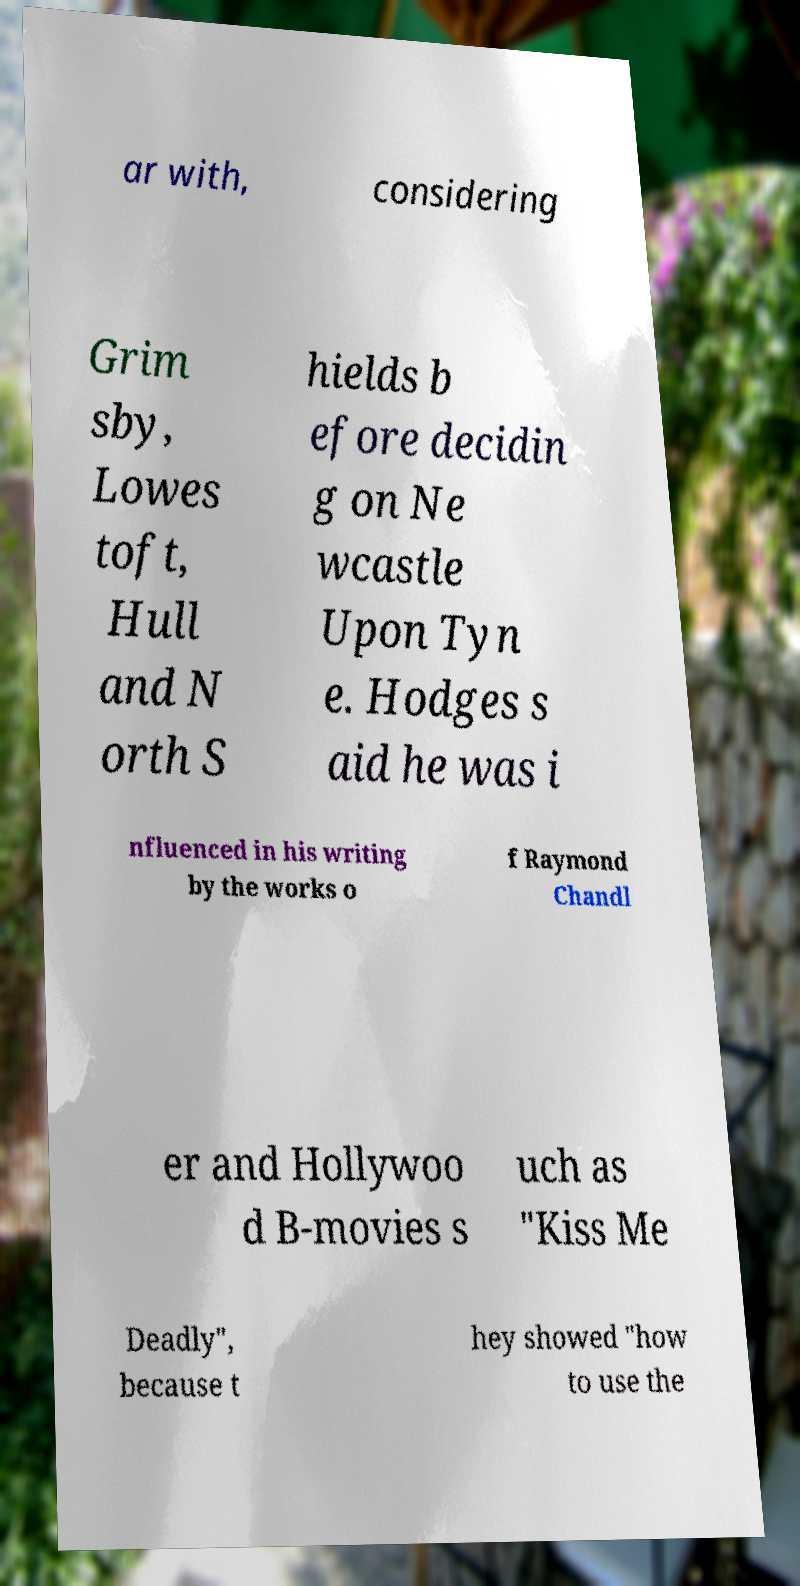What messages or text are displayed in this image? I need them in a readable, typed format. ar with, considering Grim sby, Lowes toft, Hull and N orth S hields b efore decidin g on Ne wcastle Upon Tyn e. Hodges s aid he was i nfluenced in his writing by the works o f Raymond Chandl er and Hollywoo d B-movies s uch as "Kiss Me Deadly", because t hey showed "how to use the 